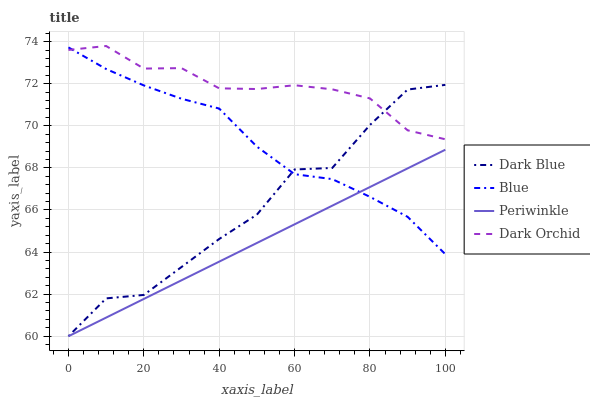Does Periwinkle have the minimum area under the curve?
Answer yes or no. Yes. Does Dark Orchid have the maximum area under the curve?
Answer yes or no. Yes. Does Dark Blue have the minimum area under the curve?
Answer yes or no. No. Does Dark Blue have the maximum area under the curve?
Answer yes or no. No. Is Periwinkle the smoothest?
Answer yes or no. Yes. Is Dark Blue the roughest?
Answer yes or no. Yes. Is Dark Blue the smoothest?
Answer yes or no. No. Is Periwinkle the roughest?
Answer yes or no. No. Does Dark Orchid have the lowest value?
Answer yes or no. No. Does Dark Blue have the highest value?
Answer yes or no. No. Is Periwinkle less than Dark Orchid?
Answer yes or no. Yes. Is Dark Orchid greater than Periwinkle?
Answer yes or no. Yes. Does Periwinkle intersect Dark Orchid?
Answer yes or no. No. 